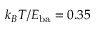Convert formula to latex. <formula><loc_0><loc_0><loc_500><loc_500>k _ { B } T / E _ { b a } = 0 . 3 5</formula> 